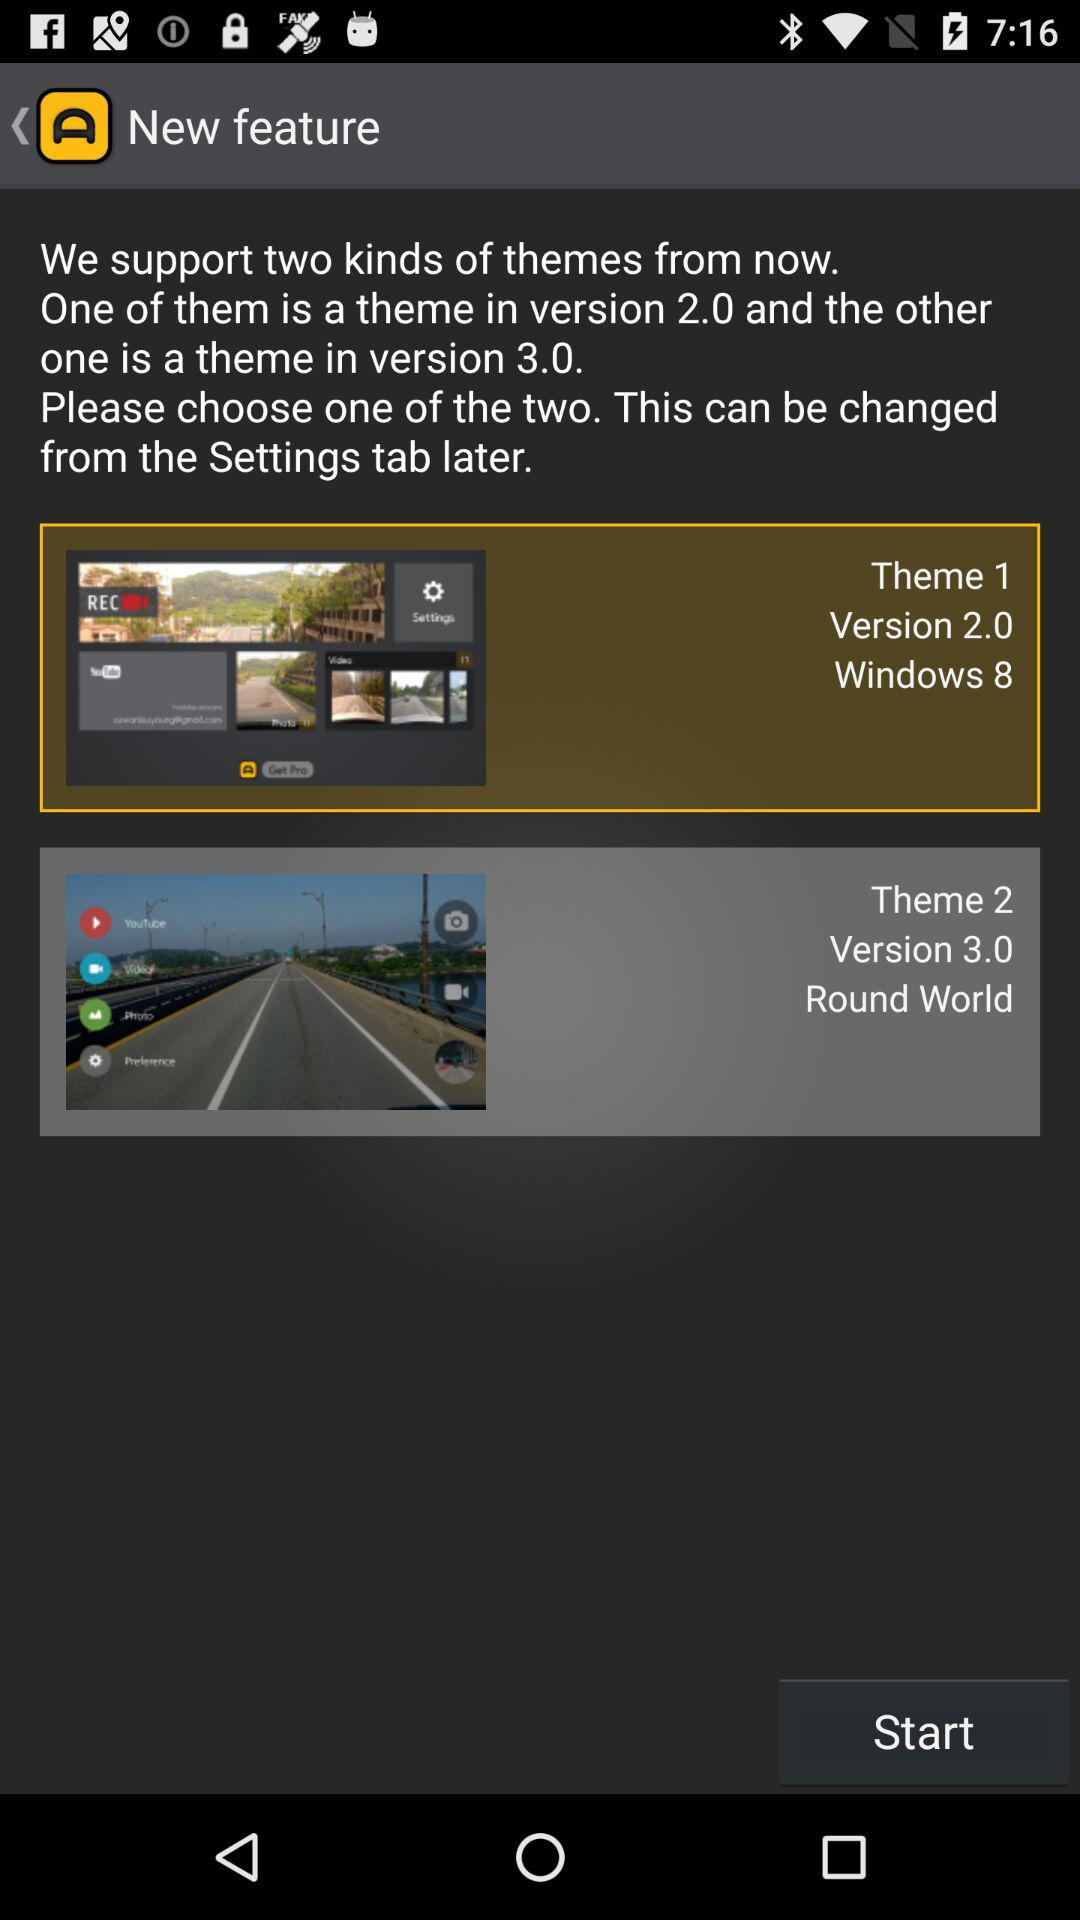By using what tab can themes be changed? Themes can be changed by using the "Settings" tab. 